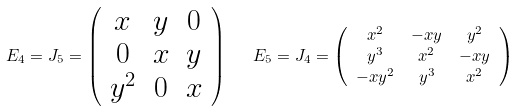Convert formula to latex. <formula><loc_0><loc_0><loc_500><loc_500>E _ { 4 } = J _ { 5 } = \left ( \begin{array} { c c c } x & y & 0 \\ 0 & x & y \\ y ^ { 2 } & 0 & x \end{array} \right ) \quad & E _ { 5 } = J _ { 4 } = \left ( \begin{array} { c c c } x ^ { 2 } & - x y & y ^ { 2 } \\ y ^ { 3 } & x ^ { 2 } & - x y \\ - x y ^ { 2 } & y ^ { 3 } & x ^ { 2 } \end{array} \right )</formula> 